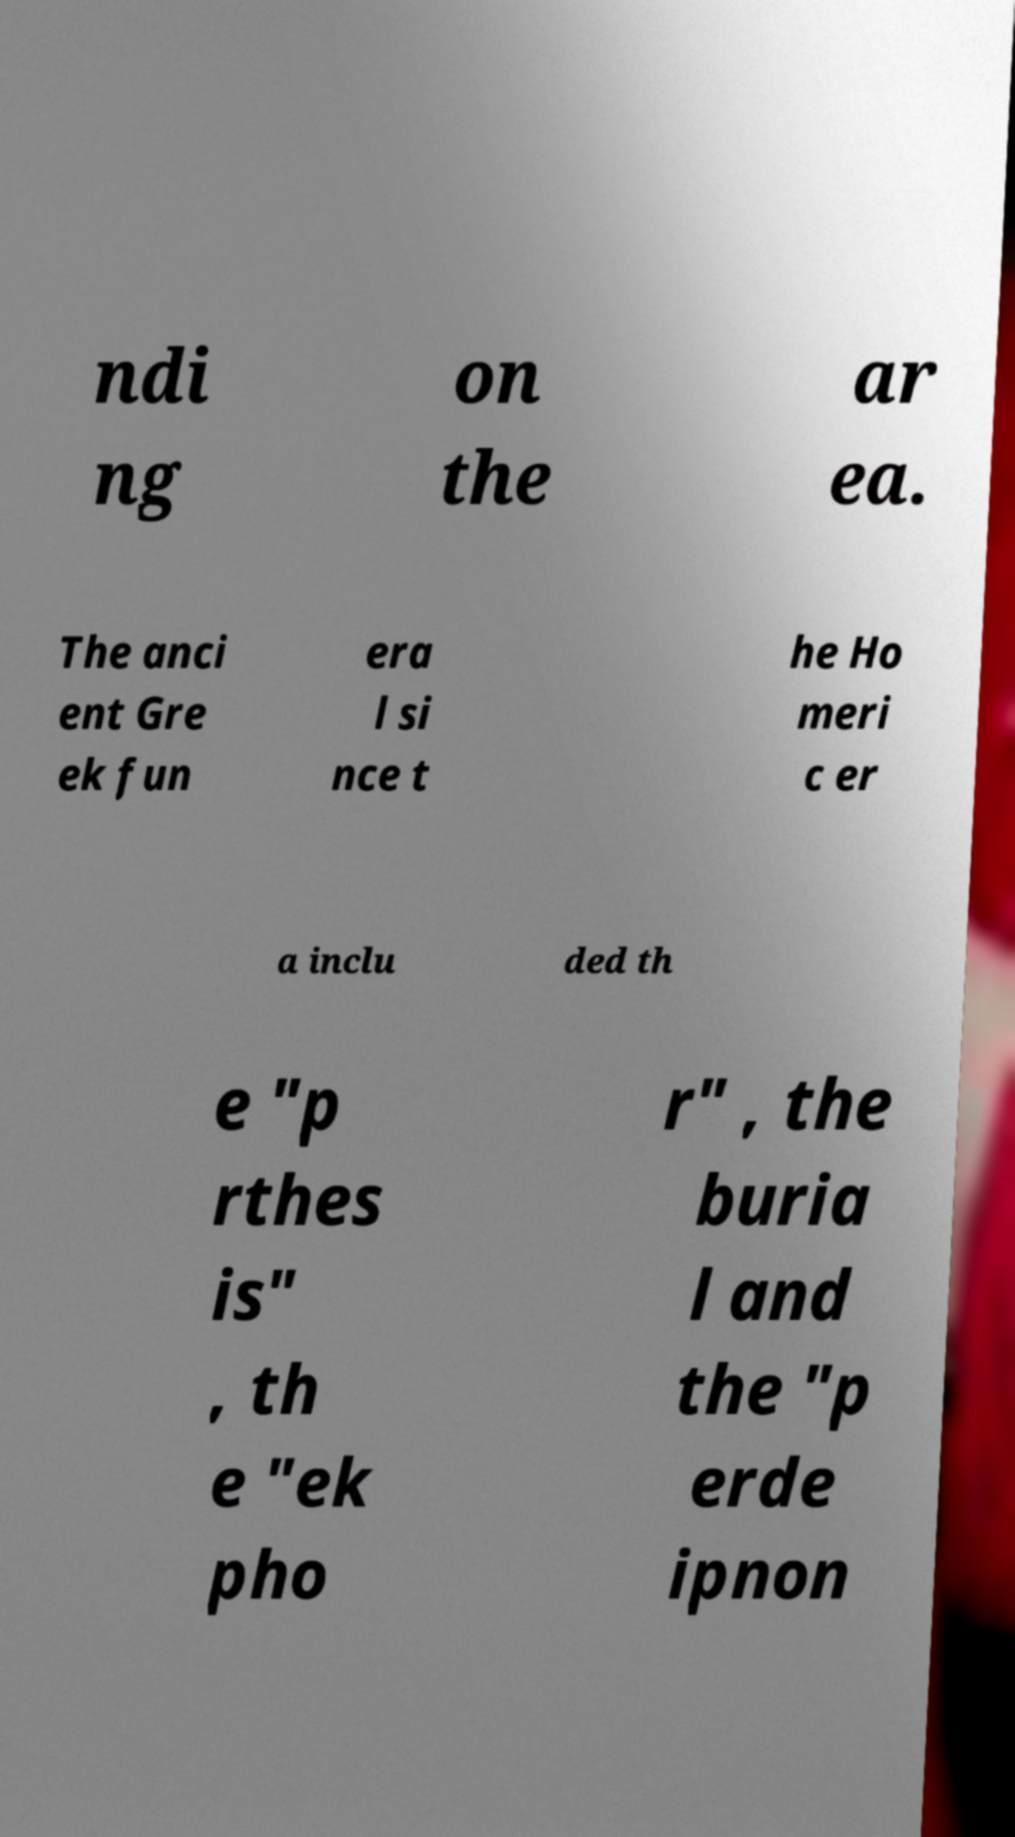Could you extract and type out the text from this image? ndi ng on the ar ea. The anci ent Gre ek fun era l si nce t he Ho meri c er a inclu ded th e "p rthes is" , th e "ek pho r" , the buria l and the "p erde ipnon 